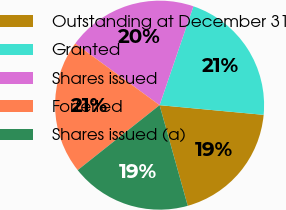Convert chart to OTSL. <chart><loc_0><loc_0><loc_500><loc_500><pie_chart><fcel>Outstanding at December 31<fcel>Granted<fcel>Shares issued<fcel>Forfeited<fcel>Shares issued (a)<nl><fcel>19.18%<fcel>21.23%<fcel>20.2%<fcel>20.72%<fcel>18.67%<nl></chart> 